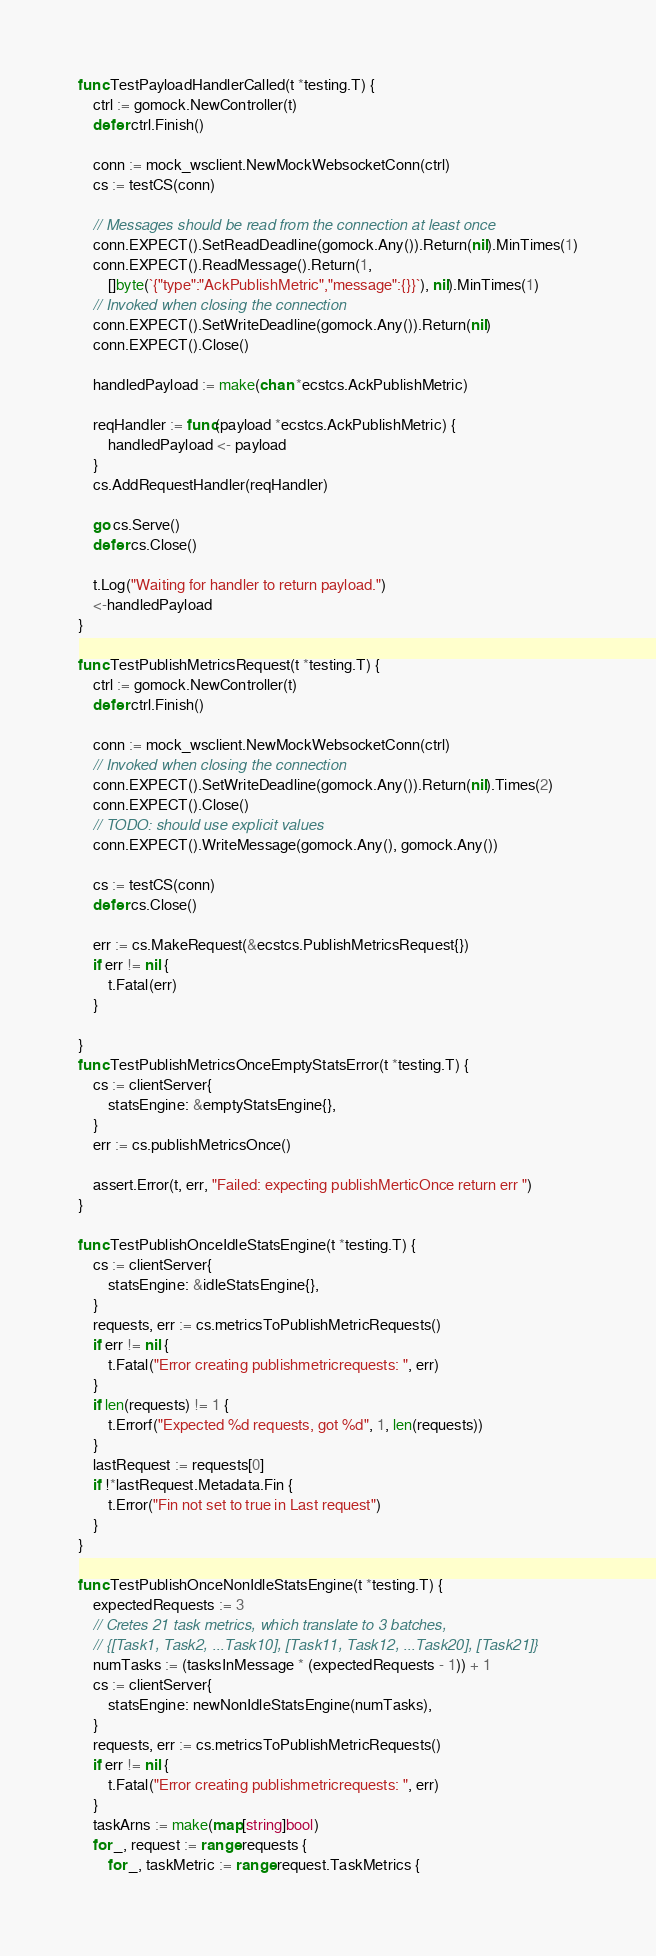Convert code to text. <code><loc_0><loc_0><loc_500><loc_500><_Go_>
func TestPayloadHandlerCalled(t *testing.T) {
	ctrl := gomock.NewController(t)
	defer ctrl.Finish()

	conn := mock_wsclient.NewMockWebsocketConn(ctrl)
	cs := testCS(conn)

	// Messages should be read from the connection at least once
	conn.EXPECT().SetReadDeadline(gomock.Any()).Return(nil).MinTimes(1)
	conn.EXPECT().ReadMessage().Return(1,
		[]byte(`{"type":"AckPublishMetric","message":{}}`), nil).MinTimes(1)
	// Invoked when closing the connection
	conn.EXPECT().SetWriteDeadline(gomock.Any()).Return(nil)
	conn.EXPECT().Close()

	handledPayload := make(chan *ecstcs.AckPublishMetric)

	reqHandler := func(payload *ecstcs.AckPublishMetric) {
		handledPayload <- payload
	}
	cs.AddRequestHandler(reqHandler)

	go cs.Serve()
	defer cs.Close()

	t.Log("Waiting for handler to return payload.")
	<-handledPayload
}

func TestPublishMetricsRequest(t *testing.T) {
	ctrl := gomock.NewController(t)
	defer ctrl.Finish()

	conn := mock_wsclient.NewMockWebsocketConn(ctrl)
	// Invoked when closing the connection
	conn.EXPECT().SetWriteDeadline(gomock.Any()).Return(nil).Times(2)
	conn.EXPECT().Close()
	// TODO: should use explicit values
	conn.EXPECT().WriteMessage(gomock.Any(), gomock.Any())

	cs := testCS(conn)
	defer cs.Close()

	err := cs.MakeRequest(&ecstcs.PublishMetricsRequest{})
	if err != nil {
		t.Fatal(err)
	}

}
func TestPublishMetricsOnceEmptyStatsError(t *testing.T) {
	cs := clientServer{
		statsEngine: &emptyStatsEngine{},
	}
	err := cs.publishMetricsOnce()

	assert.Error(t, err, "Failed: expecting publishMerticOnce return err ")
}

func TestPublishOnceIdleStatsEngine(t *testing.T) {
	cs := clientServer{
		statsEngine: &idleStatsEngine{},
	}
	requests, err := cs.metricsToPublishMetricRequests()
	if err != nil {
		t.Fatal("Error creating publishmetricrequests: ", err)
	}
	if len(requests) != 1 {
		t.Errorf("Expected %d requests, got %d", 1, len(requests))
	}
	lastRequest := requests[0]
	if !*lastRequest.Metadata.Fin {
		t.Error("Fin not set to true in Last request")
	}
}

func TestPublishOnceNonIdleStatsEngine(t *testing.T) {
	expectedRequests := 3
	// Cretes 21 task metrics, which translate to 3 batches,
	// {[Task1, Task2, ...Task10], [Task11, Task12, ...Task20], [Task21]}
	numTasks := (tasksInMessage * (expectedRequests - 1)) + 1
	cs := clientServer{
		statsEngine: newNonIdleStatsEngine(numTasks),
	}
	requests, err := cs.metricsToPublishMetricRequests()
	if err != nil {
		t.Fatal("Error creating publishmetricrequests: ", err)
	}
	taskArns := make(map[string]bool)
	for _, request := range requests {
		for _, taskMetric := range request.TaskMetrics {</code> 